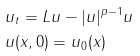<formula> <loc_0><loc_0><loc_500><loc_500>& u _ { t } = L u - | u | ^ { p - 1 } u \\ & u ( x , 0 ) = u _ { 0 } ( x )</formula> 